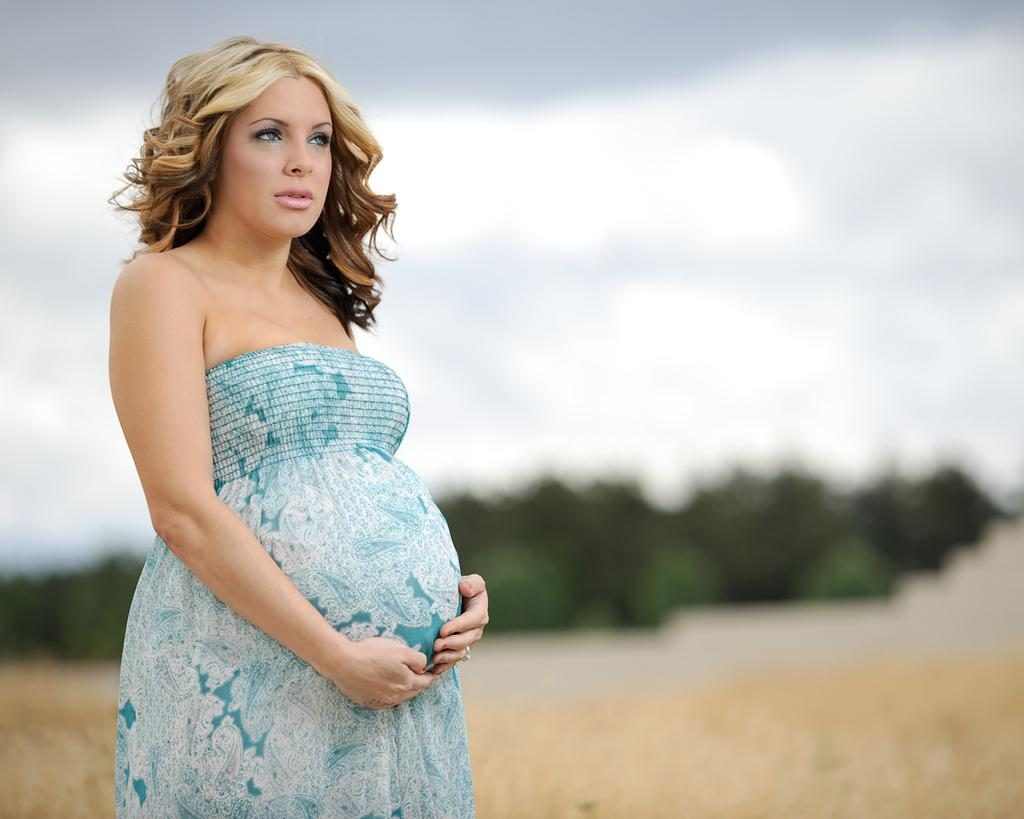What is the main subject of the image? There is a woman standing in the image. What can be seen in the background of the image? There is a group of trees and plants visible in the background of the image. What part of the natural environment is visible in the image? The sky is visible in the background of the image. What type of beam is holding up the tent at the party in the image? There is no tent or party present in the image, and therefore no beam can be observed. 